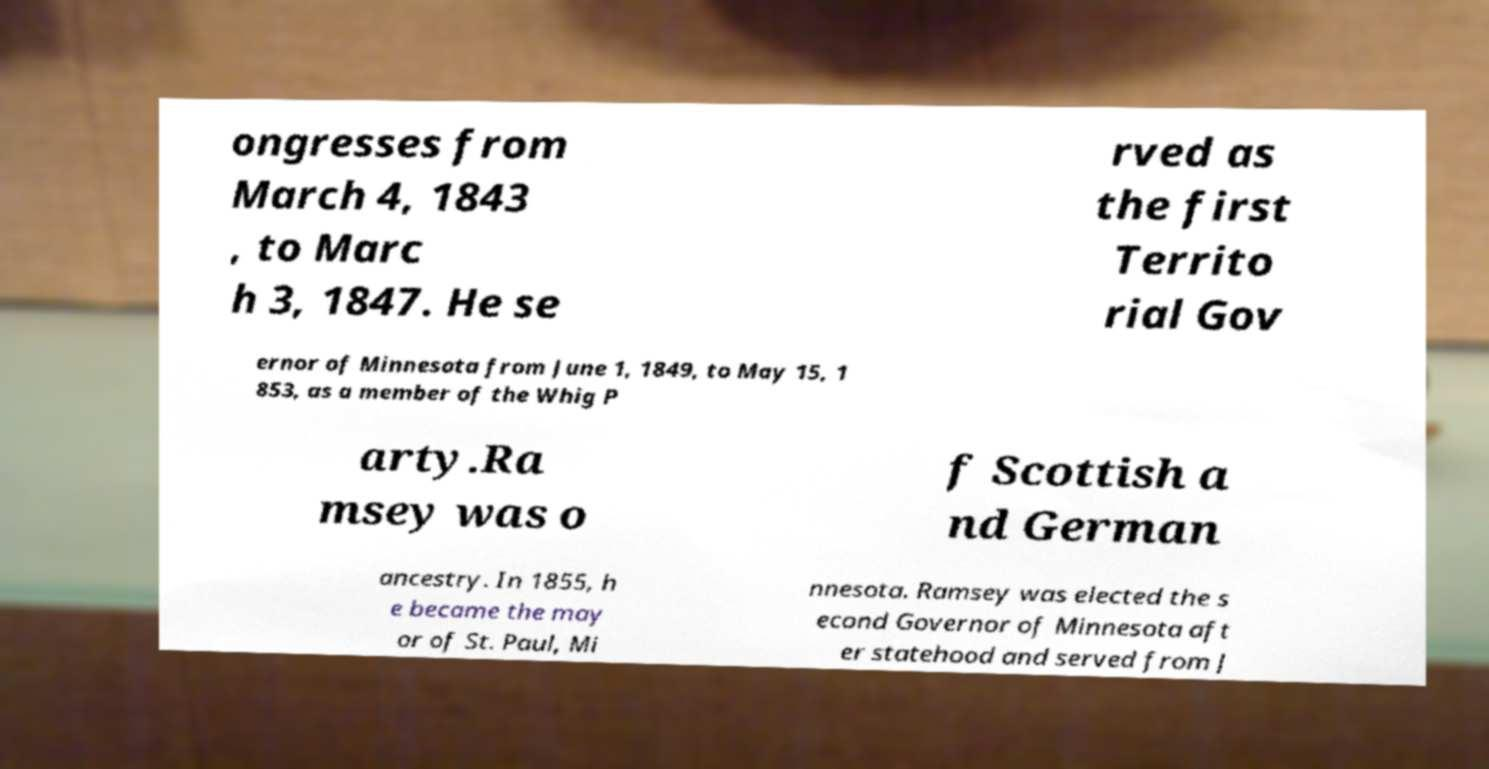What messages or text are displayed in this image? I need them in a readable, typed format. ongresses from March 4, 1843 , to Marc h 3, 1847. He se rved as the first Territo rial Gov ernor of Minnesota from June 1, 1849, to May 15, 1 853, as a member of the Whig P arty.Ra msey was o f Scottish a nd German ancestry. In 1855, h e became the may or of St. Paul, Mi nnesota. Ramsey was elected the s econd Governor of Minnesota aft er statehood and served from J 